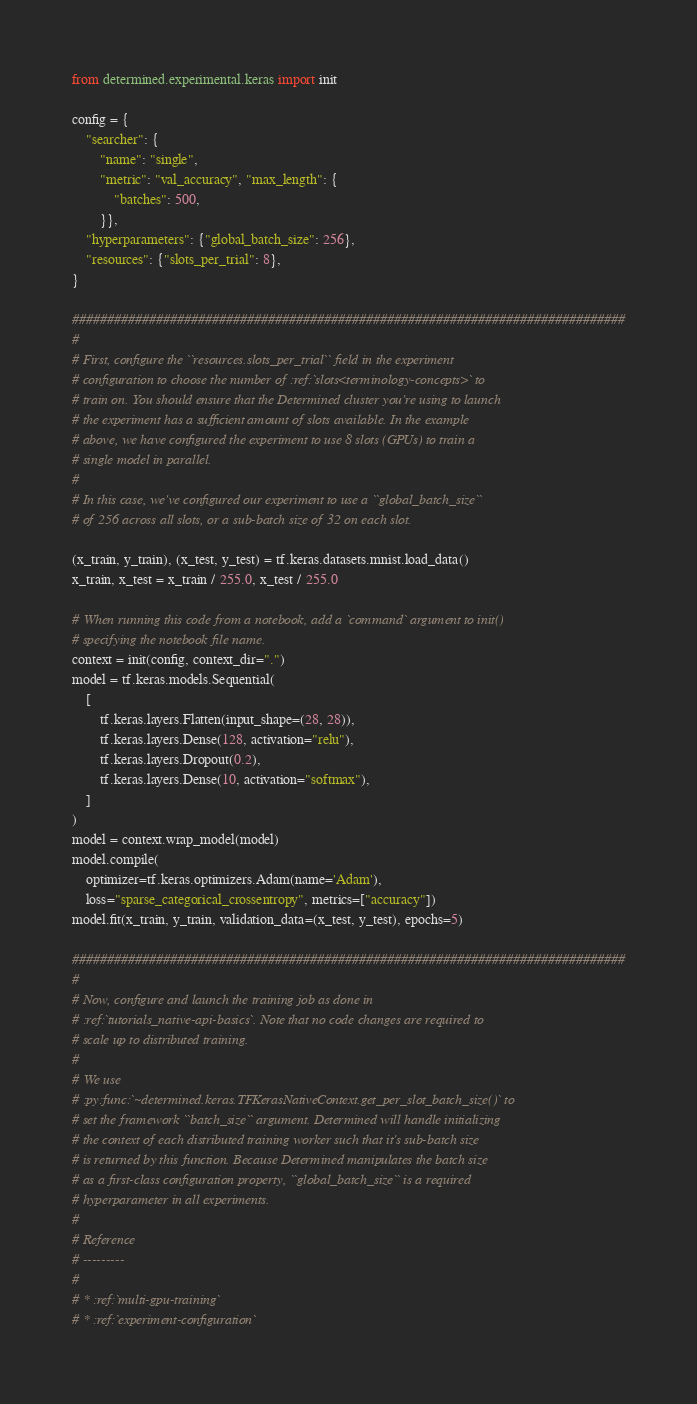Convert code to text. <code><loc_0><loc_0><loc_500><loc_500><_Python_>from determined.experimental.keras import init

config = {
    "searcher": {
        "name": "single",
        "metric": "val_accuracy", "max_length": {
            "batches": 500,
        }},
    "hyperparameters": {"global_batch_size": 256},
    "resources": {"slots_per_trial": 8},
}

###############################################################################
#
# First, configure the ``resources.slots_per_trial`` field in the experiment
# configuration to choose the number of :ref:`slots<terminology-concepts>` to
# train on. You should ensure that the Determined cluster you're using to launch
# the experiment has a sufficient amount of slots available. In the example
# above, we have configured the experiment to use 8 slots (GPUs) to train a
# single model in parallel.
#
# In this case, we've configured our experiment to use a ``global_batch_size``
# of 256 across all slots, or a sub-batch size of 32 on each slot.

(x_train, y_train), (x_test, y_test) = tf.keras.datasets.mnist.load_data()
x_train, x_test = x_train / 255.0, x_test / 255.0

# When running this code from a notebook, add a `command` argument to init()
# specifying the notebook file name.
context = init(config, context_dir=".")
model = tf.keras.models.Sequential(
    [
        tf.keras.layers.Flatten(input_shape=(28, 28)),
        tf.keras.layers.Dense(128, activation="relu"),
        tf.keras.layers.Dropout(0.2),
        tf.keras.layers.Dense(10, activation="softmax"),
    ]
)
model = context.wrap_model(model)
model.compile(
    optimizer=tf.keras.optimizers.Adam(name='Adam'), 
    loss="sparse_categorical_crossentropy", metrics=["accuracy"])
model.fit(x_train, y_train, validation_data=(x_test, y_test), epochs=5)

###############################################################################
#
# Now, configure and launch the training job as done in
# :ref:`tutorials_native-api-basics`. Note that no code changes are required to
# scale up to distributed training.
#
# We use
# :py:func:`~determined.keras.TFKerasNativeContext.get_per_slot_batch_size()` to
# set the framework ``batch_size`` argument. Determined will handle initializing
# the context of each distributed training worker such that it's sub-batch size
# is returned by this function. Because Determined manipulates the batch size
# as a first-class configuration property, ``global_batch_size`` is a required
# hyperparameter in all experiments.
#
# Reference
# ---------
#
# * :ref:`multi-gpu-training`
# * :ref:`experiment-configuration`
</code> 